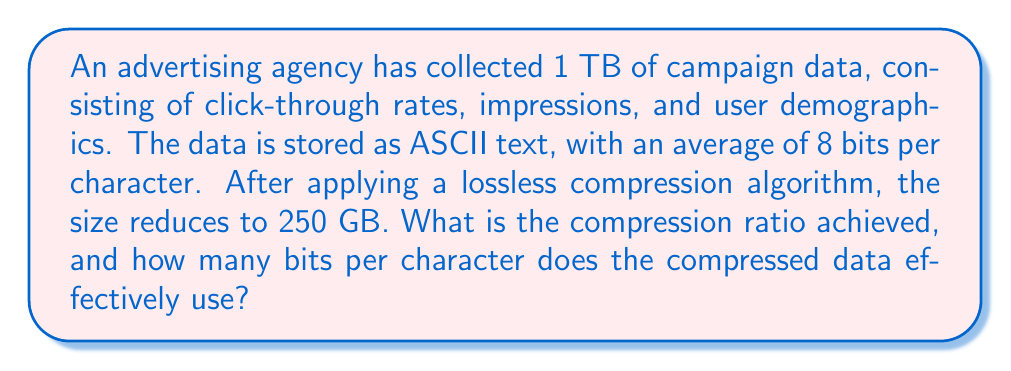Help me with this question. To solve this problem, we need to follow these steps:

1. Calculate the compression ratio:
   The compression ratio is defined as the ratio of uncompressed size to compressed size.
   
   $$\text{Compression Ratio} = \frac{\text{Uncompressed Size}}{\text{Compressed Size}}$$

   Uncompressed size = 1 TB = 1000 GB
   Compressed size = 250 GB

   $$\text{Compression Ratio} = \frac{1000 \text{ GB}}{250 \text{ GB}} = 4:1$$

2. Calculate the effective bits per character in the compressed data:
   First, we need to convert the sizes to bits:
   
   Uncompressed: 1 TB = 1000 GB = $1000 \times 8 \times 10^9$ bits = $8 \times 10^{12}$ bits
   Compressed: 250 GB = $250 \times 8 \times 10^9$ bits = $2 \times 10^{12}$ bits

   We know that the uncompressed data uses 8 bits per character on average.
   To find the number of characters, divide the total bits by 8:

   $$\text{Number of characters} = \frac{8 \times 10^{12}}{8} = 10^{12}$$

   Now, to find the effective bits per character in the compressed data:

   $$\text{Effective bits per character} = \frac{\text{Compressed size in bits}}{\text{Number of characters}}$$

   $$\text{Effective bits per character} = \frac{2 \times 10^{12}}{10^{12}} = 2$$

Therefore, the compressed data effectively uses 2 bits per character.
Answer: The compression ratio achieved is 4:1, and the compressed data effectively uses 2 bits per character. 